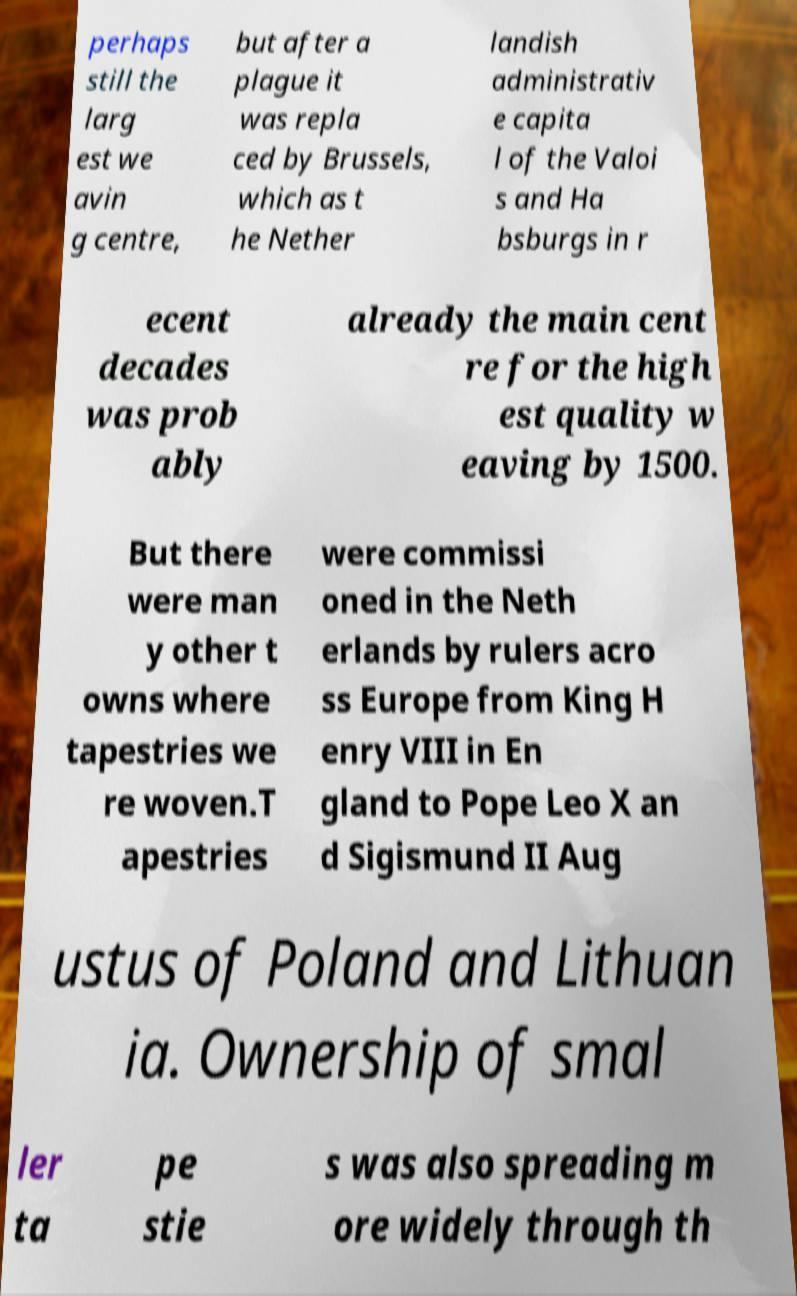Could you assist in decoding the text presented in this image and type it out clearly? perhaps still the larg est we avin g centre, but after a plague it was repla ced by Brussels, which as t he Nether landish administrativ e capita l of the Valoi s and Ha bsburgs in r ecent decades was prob ably already the main cent re for the high est quality w eaving by 1500. But there were man y other t owns where tapestries we re woven.T apestries were commissi oned in the Neth erlands by rulers acro ss Europe from King H enry VIII in En gland to Pope Leo X an d Sigismund II Aug ustus of Poland and Lithuan ia. Ownership of smal ler ta pe stie s was also spreading m ore widely through th 